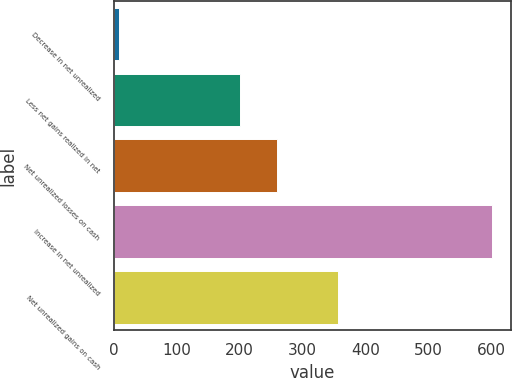<chart> <loc_0><loc_0><loc_500><loc_500><bar_chart><fcel>Decrease in net unrealized<fcel>Less net gains realized in net<fcel>Net unrealized losses on cash<fcel>Increase in net unrealized<fcel>Net unrealized gains on cash<nl><fcel>8<fcel>200<fcel>259.3<fcel>601<fcel>356<nl></chart> 